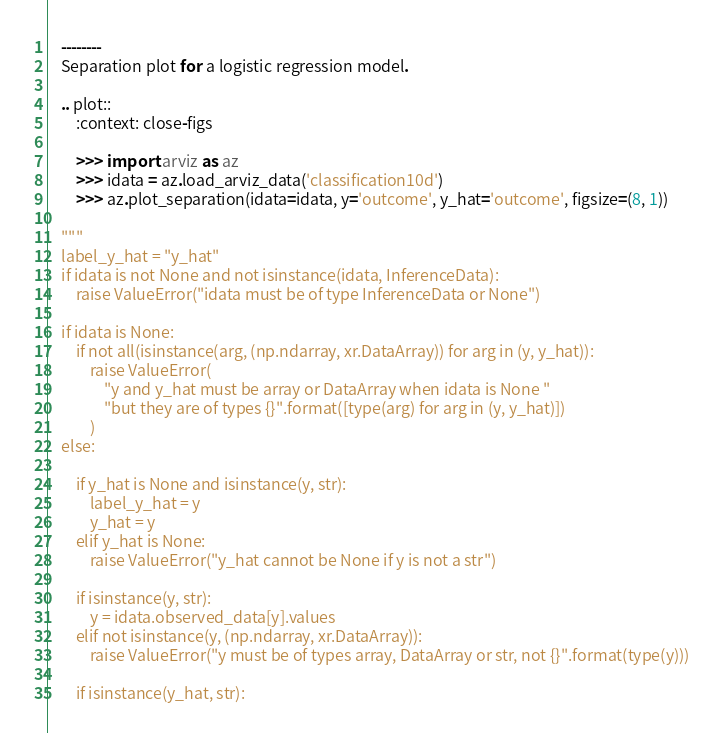<code> <loc_0><loc_0><loc_500><loc_500><_Python_>    --------
    Separation plot for a logistic regression model.

    .. plot::
        :context: close-figs

        >>> import arviz as az
        >>> idata = az.load_arviz_data('classification10d')
        >>> az.plot_separation(idata=idata, y='outcome', y_hat='outcome', figsize=(8, 1))

    """
    label_y_hat = "y_hat"
    if idata is not None and not isinstance(idata, InferenceData):
        raise ValueError("idata must be of type InferenceData or None")

    if idata is None:
        if not all(isinstance(arg, (np.ndarray, xr.DataArray)) for arg in (y, y_hat)):
            raise ValueError(
                "y and y_hat must be array or DataArray when idata is None "
                "but they are of types {}".format([type(arg) for arg in (y, y_hat)])
            )
    else:

        if y_hat is None and isinstance(y, str):
            label_y_hat = y
            y_hat = y
        elif y_hat is None:
            raise ValueError("y_hat cannot be None if y is not a str")

        if isinstance(y, str):
            y = idata.observed_data[y].values
        elif not isinstance(y, (np.ndarray, xr.DataArray)):
            raise ValueError("y must be of types array, DataArray or str, not {}".format(type(y)))

        if isinstance(y_hat, str):</code> 